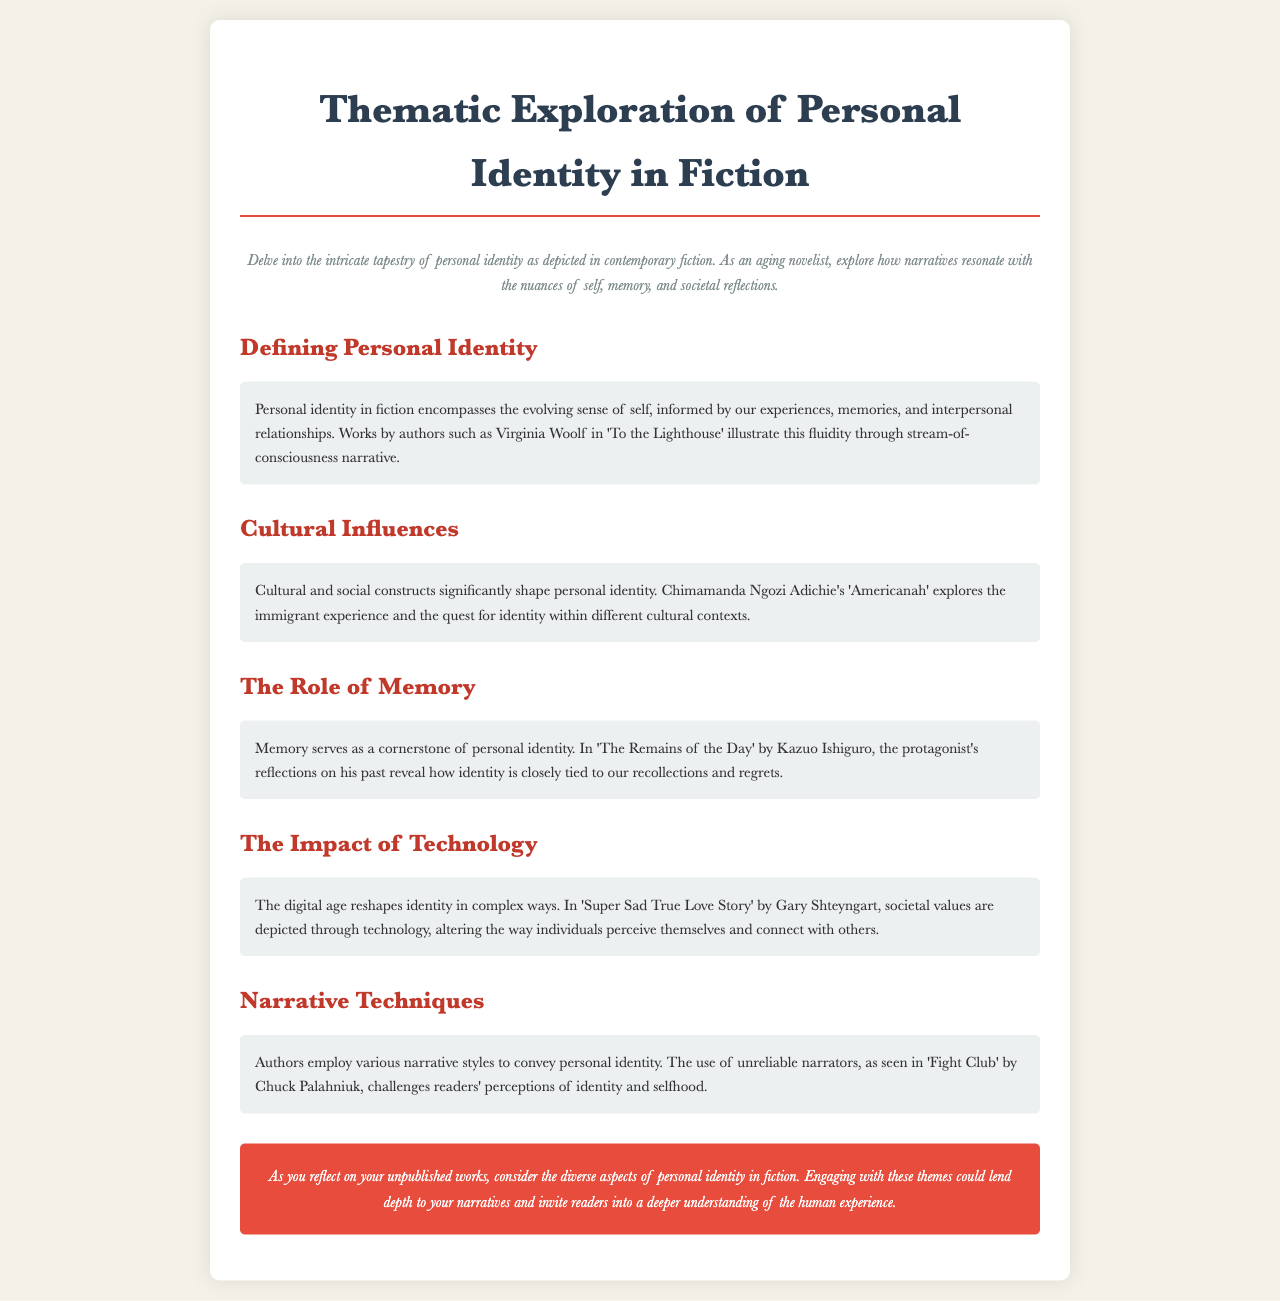what is the title of the brochure? The title of the brochure is presented prominently at the top of the document.
Answer: Thematic Exploration of Personal Identity in Fiction who is an author mentioned in the section about memory? The document refers to specific authors in various sections, including one that focuses on memory.
Answer: Kazuo Ishiguro which narrative technique is highlighted in the section on narrative techniques? The document discusses different narrative styles, particularly looking at one specific technique.
Answer: unreliable narrators what theme does Chimamanda Ngozi Adichie's work explore? The document summarizes themes of cultural influences through a specific author's work.
Answer: immigrant experience how does technology impact identity according to the document? The document describes the effects of technology on identity in a specific work of fiction.
Answer: reshapes identity how is personal identity defined in the brochure? The document provides a description or definition in the first section dedicated to personal identity.
Answer: evolving sense of self 